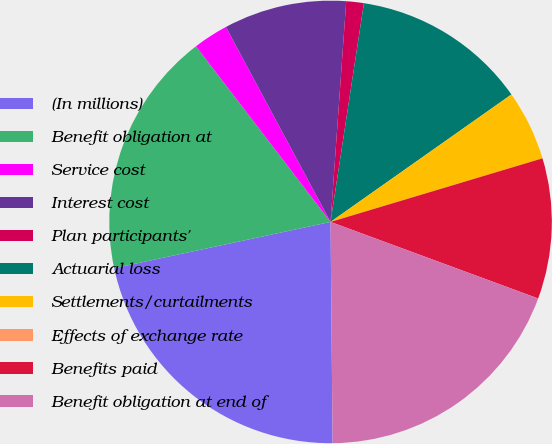Convert chart. <chart><loc_0><loc_0><loc_500><loc_500><pie_chart><fcel>(In millions)<fcel>Benefit obligation at<fcel>Service cost<fcel>Interest cost<fcel>Plan participants'<fcel>Actuarial loss<fcel>Settlements/curtailments<fcel>Effects of exchange rate<fcel>Benefits paid<fcel>Benefit obligation at end of<nl><fcel>21.79%<fcel>17.95%<fcel>2.56%<fcel>8.97%<fcel>1.28%<fcel>12.82%<fcel>5.13%<fcel>0.0%<fcel>10.26%<fcel>19.23%<nl></chart> 